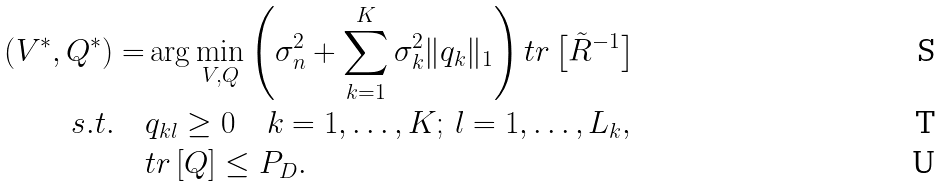<formula> <loc_0><loc_0><loc_500><loc_500>\left ( V ^ { * } , Q ^ { * } \right ) = & \arg \min _ { V , Q } \left ( \sigma _ { n } ^ { 2 } + \sum _ { k = 1 } ^ { K } \sigma _ { k } ^ { 2 } \| q _ { k } \| _ { 1 } \right ) t r \left [ \tilde { R } ^ { - 1 } \right ] \\ s . t . \quad & q _ { k l } \geq 0 \quad k = 1 , \dots , K ; \, l = 1 , \dots , L _ { k } , \\ & t r \left [ Q \right ] \leq P _ { D } .</formula> 